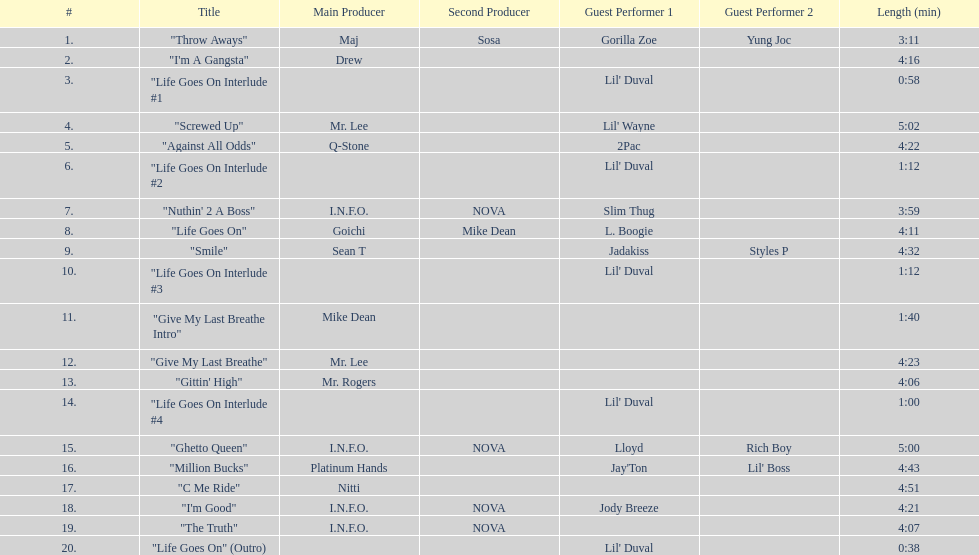How many tracks on trae's album "life goes on"? 20. Could you parse the entire table? {'header': ['#', 'Title', 'Main Producer', 'Second Producer', 'Guest Performer 1', 'Guest Performer 2', 'Length (min)'], 'rows': [['1.', '"Throw Aways"', 'Maj', 'Sosa', 'Gorilla Zoe', 'Yung Joc', '3:11'], ['2.', '"I\'m A Gangsta"', 'Drew', '', '', '', '4:16'], ['3.', '"Life Goes On Interlude #1', '', '', "Lil' Duval", '', '0:58'], ['4.', '"Screwed Up"', 'Mr. Lee', '', "Lil' Wayne", '', '5:02'], ['5.', '"Against All Odds"', 'Q-Stone', '', '2Pac', '', '4:22'], ['6.', '"Life Goes On Interlude #2', '', '', "Lil' Duval", '', '1:12'], ['7.', '"Nuthin\' 2 A Boss"', 'I.N.F.O.', 'NOVA', 'Slim Thug', '', '3:59'], ['8.', '"Life Goes On"', 'Goichi', 'Mike Dean', 'L. Boogie', '', '4:11'], ['9.', '"Smile"', 'Sean T', '', 'Jadakiss', 'Styles P', '4:32'], ['10.', '"Life Goes On Interlude #3', '', '', "Lil' Duval", '', '1:12'], ['11.', '"Give My Last Breathe Intro"', 'Mike Dean', '', '', '', '1:40'], ['12.', '"Give My Last Breathe"', 'Mr. Lee', '', '', '', '4:23'], ['13.', '"Gittin\' High"', 'Mr. Rogers', '', '', '', '4:06'], ['14.', '"Life Goes On Interlude #4', '', '', "Lil' Duval", '', '1:00'], ['15.', '"Ghetto Queen"', 'I.N.F.O.', 'NOVA', 'Lloyd', 'Rich Boy', '5:00'], ['16.', '"Million Bucks"', 'Platinum Hands', '', "Jay'Ton", "Lil' Boss", '4:43'], ['17.', '"C Me Ride"', 'Nitti', '', '', '', '4:51'], ['18.', '"I\'m Good"', 'I.N.F.O.', 'NOVA', 'Jody Breeze', '', '4:21'], ['19.', '"The Truth"', 'I.N.F.O.', 'NOVA', '', '', '4:07'], ['20.', '"Life Goes On" (Outro)', '', '', "Lil' Duval", '', '0:38']]} 